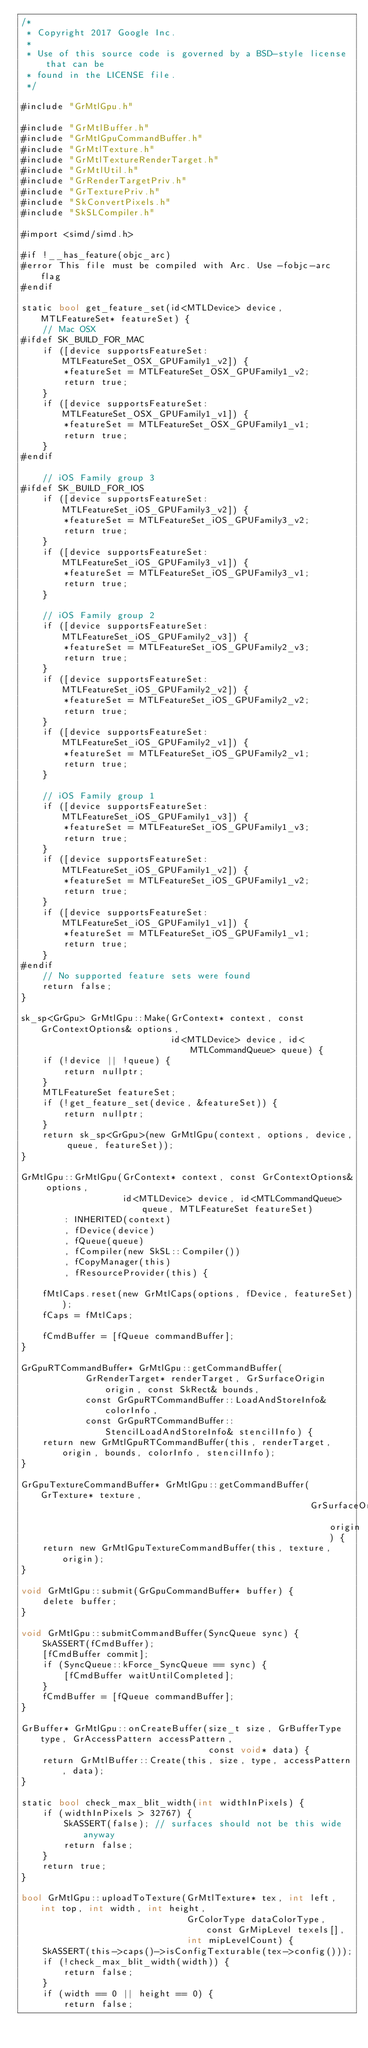Convert code to text. <code><loc_0><loc_0><loc_500><loc_500><_ObjectiveC_>/*
 * Copyright 2017 Google Inc.
 *
 * Use of this source code is governed by a BSD-style license that can be
 * found in the LICENSE file.
 */

#include "GrMtlGpu.h"

#include "GrMtlBuffer.h"
#include "GrMtlGpuCommandBuffer.h"
#include "GrMtlTexture.h"
#include "GrMtlTextureRenderTarget.h"
#include "GrMtlUtil.h"
#include "GrRenderTargetPriv.h"
#include "GrTexturePriv.h"
#include "SkConvertPixels.h"
#include "SkSLCompiler.h"

#import <simd/simd.h>

#if !__has_feature(objc_arc)
#error This file must be compiled with Arc. Use -fobjc-arc flag
#endif

static bool get_feature_set(id<MTLDevice> device, MTLFeatureSet* featureSet) {
    // Mac OSX
#ifdef SK_BUILD_FOR_MAC
    if ([device supportsFeatureSet:MTLFeatureSet_OSX_GPUFamily1_v2]) {
        *featureSet = MTLFeatureSet_OSX_GPUFamily1_v2;
        return true;
    }
    if ([device supportsFeatureSet:MTLFeatureSet_OSX_GPUFamily1_v1]) {
        *featureSet = MTLFeatureSet_OSX_GPUFamily1_v1;
        return true;
    }
#endif

    // iOS Family group 3
#ifdef SK_BUILD_FOR_IOS
    if ([device supportsFeatureSet:MTLFeatureSet_iOS_GPUFamily3_v2]) {
        *featureSet = MTLFeatureSet_iOS_GPUFamily3_v2;
        return true;
    }
    if ([device supportsFeatureSet:MTLFeatureSet_iOS_GPUFamily3_v1]) {
        *featureSet = MTLFeatureSet_iOS_GPUFamily3_v1;
        return true;
    }

    // iOS Family group 2
    if ([device supportsFeatureSet:MTLFeatureSet_iOS_GPUFamily2_v3]) {
        *featureSet = MTLFeatureSet_iOS_GPUFamily2_v3;
        return true;
    }
    if ([device supportsFeatureSet:MTLFeatureSet_iOS_GPUFamily2_v2]) {
        *featureSet = MTLFeatureSet_iOS_GPUFamily2_v2;
        return true;
    }
    if ([device supportsFeatureSet:MTLFeatureSet_iOS_GPUFamily2_v1]) {
        *featureSet = MTLFeatureSet_iOS_GPUFamily2_v1;
        return true;
    }

    // iOS Family group 1
    if ([device supportsFeatureSet:MTLFeatureSet_iOS_GPUFamily1_v3]) {
        *featureSet = MTLFeatureSet_iOS_GPUFamily1_v3;
        return true;
    }
    if ([device supportsFeatureSet:MTLFeatureSet_iOS_GPUFamily1_v2]) {
        *featureSet = MTLFeatureSet_iOS_GPUFamily1_v2;
        return true;
    }
    if ([device supportsFeatureSet:MTLFeatureSet_iOS_GPUFamily1_v1]) {
        *featureSet = MTLFeatureSet_iOS_GPUFamily1_v1;
        return true;
    }
#endif
    // No supported feature sets were found
    return false;
}

sk_sp<GrGpu> GrMtlGpu::Make(GrContext* context, const GrContextOptions& options,
                            id<MTLDevice> device, id<MTLCommandQueue> queue) {
    if (!device || !queue) {
        return nullptr;
    }
    MTLFeatureSet featureSet;
    if (!get_feature_set(device, &featureSet)) {
        return nullptr;
    }
    return sk_sp<GrGpu>(new GrMtlGpu(context, options, device, queue, featureSet));
}

GrMtlGpu::GrMtlGpu(GrContext* context, const GrContextOptions& options,
                   id<MTLDevice> device, id<MTLCommandQueue> queue, MTLFeatureSet featureSet)
        : INHERITED(context)
        , fDevice(device)
        , fQueue(queue)
        , fCompiler(new SkSL::Compiler())
        , fCopyManager(this)
        , fResourceProvider(this) {

    fMtlCaps.reset(new GrMtlCaps(options, fDevice, featureSet));
    fCaps = fMtlCaps;

    fCmdBuffer = [fQueue commandBuffer];
}

GrGpuRTCommandBuffer* GrMtlGpu::getCommandBuffer(
            GrRenderTarget* renderTarget, GrSurfaceOrigin origin, const SkRect& bounds,
            const GrGpuRTCommandBuffer::LoadAndStoreInfo& colorInfo,
            const GrGpuRTCommandBuffer::StencilLoadAndStoreInfo& stencilInfo) {
    return new GrMtlGpuRTCommandBuffer(this, renderTarget, origin, bounds, colorInfo, stencilInfo);
}

GrGpuTextureCommandBuffer* GrMtlGpu::getCommandBuffer(GrTexture* texture,
                                                      GrSurfaceOrigin origin) {
    return new GrMtlGpuTextureCommandBuffer(this, texture, origin);
}

void GrMtlGpu::submit(GrGpuCommandBuffer* buffer) {
    delete buffer;
}

void GrMtlGpu::submitCommandBuffer(SyncQueue sync) {
    SkASSERT(fCmdBuffer);
    [fCmdBuffer commit];
    if (SyncQueue::kForce_SyncQueue == sync) {
        [fCmdBuffer waitUntilCompleted];
    }
    fCmdBuffer = [fQueue commandBuffer];
}

GrBuffer* GrMtlGpu::onCreateBuffer(size_t size, GrBufferType type, GrAccessPattern accessPattern,
                                   const void* data) {
    return GrMtlBuffer::Create(this, size, type, accessPattern, data);
}

static bool check_max_blit_width(int widthInPixels) {
    if (widthInPixels > 32767) {
        SkASSERT(false); // surfaces should not be this wide anyway
        return false;
    }
    return true;
}

bool GrMtlGpu::uploadToTexture(GrMtlTexture* tex, int left, int top, int width, int height,
                               GrColorType dataColorType, const GrMipLevel texels[],
                               int mipLevelCount) {
    SkASSERT(this->caps()->isConfigTexturable(tex->config()));
    if (!check_max_blit_width(width)) {
        return false;
    }
    if (width == 0 || height == 0) {
        return false;</code> 